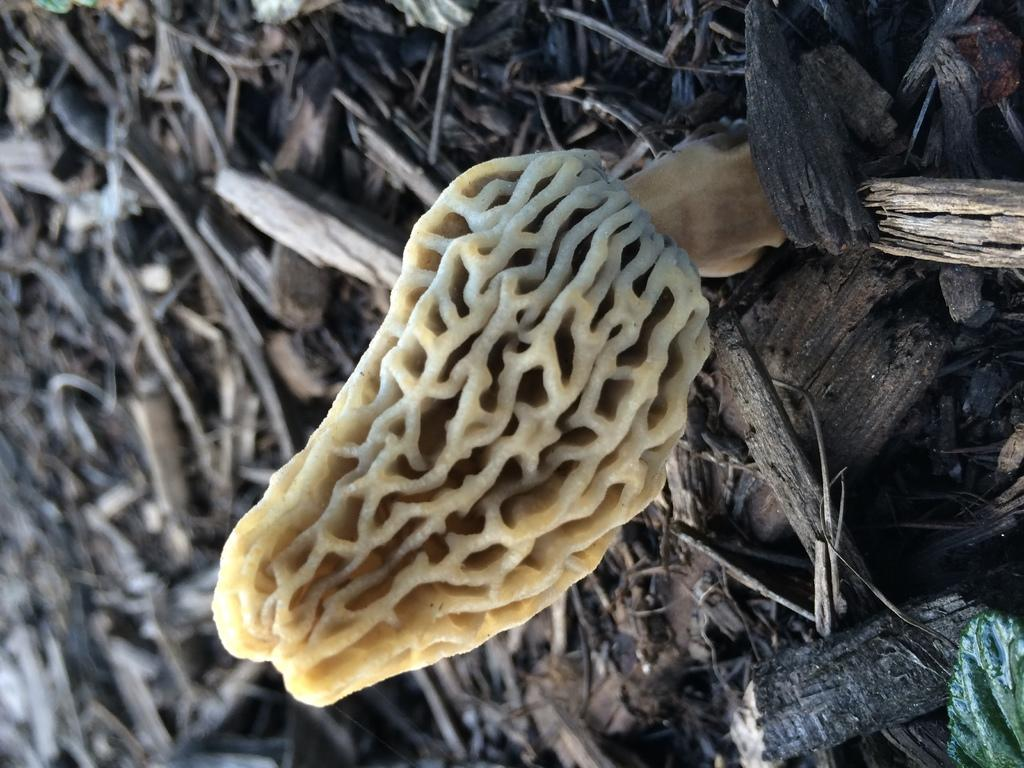What is on the ground in the image? There is something on the ground in the image. Can you describe the material of the objects on the ground? There are wooden pieces on the ground in the image. How deep is the water where the wooden pieces are swimming in the image? There is no water or swimming activity present in the image; it features wooden pieces on the ground. 